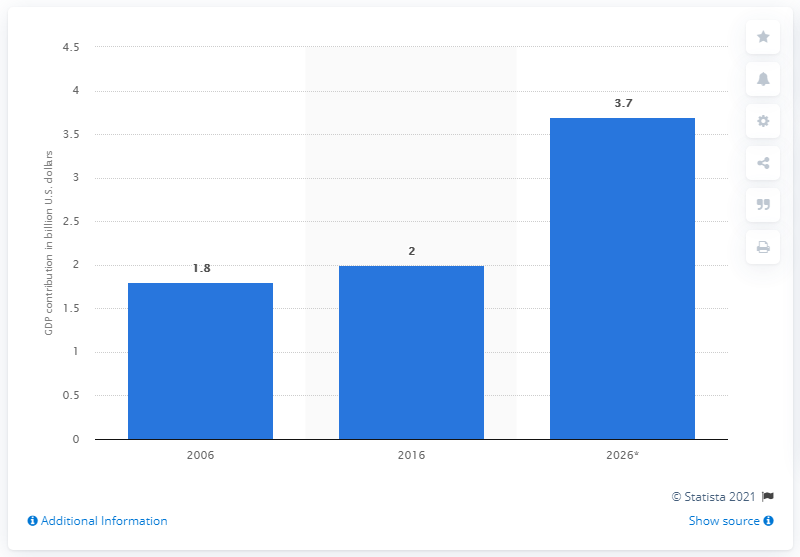Point out several critical features in this image. According to estimates, Cape Town's direct contribution to the GDP of South Africa in 2026 was 3.7%. 